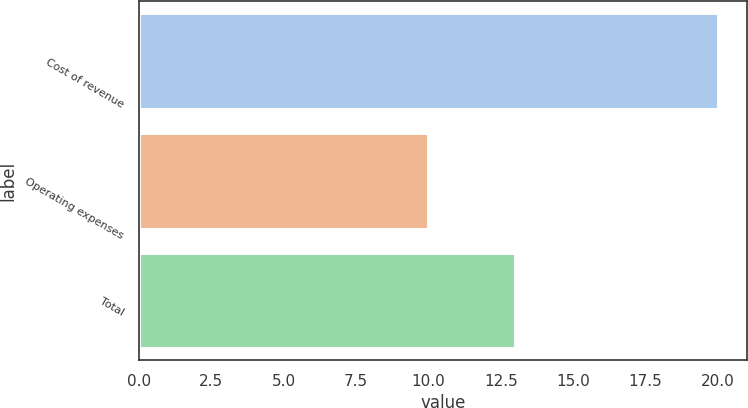Convert chart. <chart><loc_0><loc_0><loc_500><loc_500><bar_chart><fcel>Cost of revenue<fcel>Operating expenses<fcel>Total<nl><fcel>20<fcel>10<fcel>13<nl></chart> 